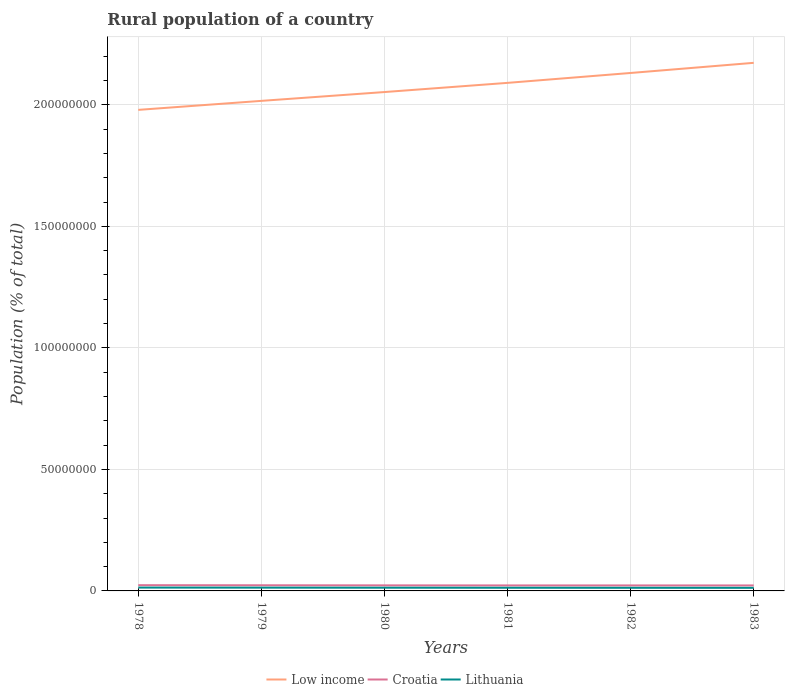How many different coloured lines are there?
Provide a short and direct response. 3. Is the number of lines equal to the number of legend labels?
Keep it short and to the point. Yes. Across all years, what is the maximum rural population in Low income?
Give a very brief answer. 1.98e+08. In which year was the rural population in Lithuania maximum?
Provide a short and direct response. 1983. What is the total rural population in Low income in the graph?
Your answer should be very brief. -3.78e+06. What is the difference between the highest and the second highest rural population in Croatia?
Provide a short and direct response. 1.10e+05. What is the difference between the highest and the lowest rural population in Low income?
Give a very brief answer. 3. How many years are there in the graph?
Provide a short and direct response. 6. Are the values on the major ticks of Y-axis written in scientific E-notation?
Keep it short and to the point. No. Does the graph contain any zero values?
Provide a succinct answer. No. What is the title of the graph?
Ensure brevity in your answer.  Rural population of a country. Does "Slovak Republic" appear as one of the legend labels in the graph?
Your response must be concise. No. What is the label or title of the X-axis?
Give a very brief answer. Years. What is the label or title of the Y-axis?
Offer a very short reply. Population (% of total). What is the Population (% of total) of Low income in 1978?
Your answer should be compact. 1.98e+08. What is the Population (% of total) of Croatia in 1978?
Keep it short and to the point. 2.37e+06. What is the Population (% of total) of Lithuania in 1978?
Provide a succinct answer. 1.37e+06. What is the Population (% of total) in Low income in 1979?
Your answer should be compact. 2.02e+08. What is the Population (% of total) in Croatia in 1979?
Your answer should be very brief. 2.33e+06. What is the Population (% of total) of Lithuania in 1979?
Make the answer very short. 1.35e+06. What is the Population (% of total) in Low income in 1980?
Your response must be concise. 2.05e+08. What is the Population (% of total) in Croatia in 1980?
Offer a terse response. 2.29e+06. What is the Population (% of total) in Lithuania in 1980?
Provide a succinct answer. 1.33e+06. What is the Population (% of total) of Low income in 1981?
Make the answer very short. 2.09e+08. What is the Population (% of total) in Croatia in 1981?
Offer a terse response. 2.26e+06. What is the Population (% of total) of Lithuania in 1981?
Provide a short and direct response. 1.31e+06. What is the Population (% of total) of Low income in 1982?
Your answer should be very brief. 2.13e+08. What is the Population (% of total) of Croatia in 1982?
Make the answer very short. 2.26e+06. What is the Population (% of total) in Lithuania in 1982?
Offer a terse response. 1.29e+06. What is the Population (% of total) of Low income in 1983?
Offer a very short reply. 2.17e+08. What is the Population (% of total) of Croatia in 1983?
Provide a succinct answer. 2.26e+06. What is the Population (% of total) of Lithuania in 1983?
Offer a very short reply. 1.27e+06. Across all years, what is the maximum Population (% of total) in Low income?
Offer a very short reply. 2.17e+08. Across all years, what is the maximum Population (% of total) in Croatia?
Offer a terse response. 2.37e+06. Across all years, what is the maximum Population (% of total) in Lithuania?
Ensure brevity in your answer.  1.37e+06. Across all years, what is the minimum Population (% of total) of Low income?
Give a very brief answer. 1.98e+08. Across all years, what is the minimum Population (% of total) in Croatia?
Your answer should be compact. 2.26e+06. Across all years, what is the minimum Population (% of total) in Lithuania?
Make the answer very short. 1.27e+06. What is the total Population (% of total) in Low income in the graph?
Provide a short and direct response. 1.24e+09. What is the total Population (% of total) of Croatia in the graph?
Give a very brief answer. 1.38e+07. What is the total Population (% of total) in Lithuania in the graph?
Give a very brief answer. 7.91e+06. What is the difference between the Population (% of total) in Low income in 1978 and that in 1979?
Provide a succinct answer. -3.70e+06. What is the difference between the Population (% of total) of Croatia in 1978 and that in 1979?
Provide a succinct answer. 3.74e+04. What is the difference between the Population (% of total) in Lithuania in 1978 and that in 1979?
Make the answer very short. 2.72e+04. What is the difference between the Population (% of total) in Low income in 1978 and that in 1980?
Offer a very short reply. -7.33e+06. What is the difference between the Population (% of total) of Croatia in 1978 and that in 1980?
Your response must be concise. 7.42e+04. What is the difference between the Population (% of total) in Lithuania in 1978 and that in 1980?
Ensure brevity in your answer.  4.83e+04. What is the difference between the Population (% of total) of Low income in 1978 and that in 1981?
Keep it short and to the point. -1.11e+07. What is the difference between the Population (% of total) in Croatia in 1978 and that in 1981?
Offer a terse response. 1.02e+05. What is the difference between the Population (% of total) in Lithuania in 1978 and that in 1981?
Provide a short and direct response. 6.77e+04. What is the difference between the Population (% of total) of Low income in 1978 and that in 1982?
Make the answer very short. -1.52e+07. What is the difference between the Population (% of total) of Croatia in 1978 and that in 1982?
Keep it short and to the point. 1.05e+05. What is the difference between the Population (% of total) in Lithuania in 1978 and that in 1982?
Your answer should be compact. 8.56e+04. What is the difference between the Population (% of total) of Low income in 1978 and that in 1983?
Provide a succinct answer. -1.94e+07. What is the difference between the Population (% of total) in Croatia in 1978 and that in 1983?
Your answer should be very brief. 1.10e+05. What is the difference between the Population (% of total) in Lithuania in 1978 and that in 1983?
Your answer should be very brief. 1.02e+05. What is the difference between the Population (% of total) in Low income in 1979 and that in 1980?
Keep it short and to the point. -3.63e+06. What is the difference between the Population (% of total) of Croatia in 1979 and that in 1980?
Your answer should be compact. 3.68e+04. What is the difference between the Population (% of total) in Lithuania in 1979 and that in 1980?
Provide a succinct answer. 2.11e+04. What is the difference between the Population (% of total) in Low income in 1979 and that in 1981?
Your response must be concise. -7.41e+06. What is the difference between the Population (% of total) of Croatia in 1979 and that in 1981?
Your answer should be compact. 6.49e+04. What is the difference between the Population (% of total) in Lithuania in 1979 and that in 1981?
Your response must be concise. 4.05e+04. What is the difference between the Population (% of total) of Low income in 1979 and that in 1982?
Offer a very short reply. -1.15e+07. What is the difference between the Population (% of total) in Croatia in 1979 and that in 1982?
Give a very brief answer. 6.79e+04. What is the difference between the Population (% of total) in Lithuania in 1979 and that in 1982?
Give a very brief answer. 5.84e+04. What is the difference between the Population (% of total) of Low income in 1979 and that in 1983?
Your answer should be very brief. -1.57e+07. What is the difference between the Population (% of total) in Croatia in 1979 and that in 1983?
Keep it short and to the point. 7.26e+04. What is the difference between the Population (% of total) of Lithuania in 1979 and that in 1983?
Offer a very short reply. 7.50e+04. What is the difference between the Population (% of total) of Low income in 1980 and that in 1981?
Offer a terse response. -3.78e+06. What is the difference between the Population (% of total) of Croatia in 1980 and that in 1981?
Keep it short and to the point. 2.81e+04. What is the difference between the Population (% of total) in Lithuania in 1980 and that in 1981?
Your answer should be very brief. 1.94e+04. What is the difference between the Population (% of total) in Low income in 1980 and that in 1982?
Keep it short and to the point. -7.85e+06. What is the difference between the Population (% of total) in Croatia in 1980 and that in 1982?
Provide a short and direct response. 3.11e+04. What is the difference between the Population (% of total) of Lithuania in 1980 and that in 1982?
Provide a succinct answer. 3.73e+04. What is the difference between the Population (% of total) of Low income in 1980 and that in 1983?
Offer a very short reply. -1.20e+07. What is the difference between the Population (% of total) in Croatia in 1980 and that in 1983?
Your answer should be very brief. 3.58e+04. What is the difference between the Population (% of total) of Lithuania in 1980 and that in 1983?
Offer a terse response. 5.39e+04. What is the difference between the Population (% of total) in Low income in 1981 and that in 1982?
Offer a very short reply. -4.07e+06. What is the difference between the Population (% of total) in Croatia in 1981 and that in 1982?
Your response must be concise. 3009. What is the difference between the Population (% of total) of Lithuania in 1981 and that in 1982?
Offer a terse response. 1.79e+04. What is the difference between the Population (% of total) in Low income in 1981 and that in 1983?
Give a very brief answer. -8.24e+06. What is the difference between the Population (% of total) in Croatia in 1981 and that in 1983?
Your answer should be very brief. 7659. What is the difference between the Population (% of total) in Lithuania in 1981 and that in 1983?
Your answer should be very brief. 3.45e+04. What is the difference between the Population (% of total) of Low income in 1982 and that in 1983?
Your answer should be compact. -4.17e+06. What is the difference between the Population (% of total) of Croatia in 1982 and that in 1983?
Your answer should be compact. 4650. What is the difference between the Population (% of total) in Lithuania in 1982 and that in 1983?
Keep it short and to the point. 1.66e+04. What is the difference between the Population (% of total) of Low income in 1978 and the Population (% of total) of Croatia in 1979?
Make the answer very short. 1.96e+08. What is the difference between the Population (% of total) of Low income in 1978 and the Population (% of total) of Lithuania in 1979?
Your answer should be compact. 1.97e+08. What is the difference between the Population (% of total) in Croatia in 1978 and the Population (% of total) in Lithuania in 1979?
Provide a short and direct response. 1.02e+06. What is the difference between the Population (% of total) of Low income in 1978 and the Population (% of total) of Croatia in 1980?
Provide a short and direct response. 1.96e+08. What is the difference between the Population (% of total) in Low income in 1978 and the Population (% of total) in Lithuania in 1980?
Keep it short and to the point. 1.97e+08. What is the difference between the Population (% of total) in Croatia in 1978 and the Population (% of total) in Lithuania in 1980?
Provide a short and direct response. 1.04e+06. What is the difference between the Population (% of total) of Low income in 1978 and the Population (% of total) of Croatia in 1981?
Your response must be concise. 1.96e+08. What is the difference between the Population (% of total) in Low income in 1978 and the Population (% of total) in Lithuania in 1981?
Provide a succinct answer. 1.97e+08. What is the difference between the Population (% of total) in Croatia in 1978 and the Population (% of total) in Lithuania in 1981?
Provide a short and direct response. 1.06e+06. What is the difference between the Population (% of total) in Low income in 1978 and the Population (% of total) in Croatia in 1982?
Give a very brief answer. 1.96e+08. What is the difference between the Population (% of total) in Low income in 1978 and the Population (% of total) in Lithuania in 1982?
Offer a terse response. 1.97e+08. What is the difference between the Population (% of total) in Croatia in 1978 and the Population (% of total) in Lithuania in 1982?
Your answer should be compact. 1.08e+06. What is the difference between the Population (% of total) of Low income in 1978 and the Population (% of total) of Croatia in 1983?
Offer a terse response. 1.96e+08. What is the difference between the Population (% of total) in Low income in 1978 and the Population (% of total) in Lithuania in 1983?
Give a very brief answer. 1.97e+08. What is the difference between the Population (% of total) of Croatia in 1978 and the Population (% of total) of Lithuania in 1983?
Keep it short and to the point. 1.09e+06. What is the difference between the Population (% of total) in Low income in 1979 and the Population (% of total) in Croatia in 1980?
Your answer should be compact. 1.99e+08. What is the difference between the Population (% of total) of Low income in 1979 and the Population (% of total) of Lithuania in 1980?
Your answer should be compact. 2.00e+08. What is the difference between the Population (% of total) in Croatia in 1979 and the Population (% of total) in Lithuania in 1980?
Your response must be concise. 1.00e+06. What is the difference between the Population (% of total) of Low income in 1979 and the Population (% of total) of Croatia in 1981?
Ensure brevity in your answer.  1.99e+08. What is the difference between the Population (% of total) of Low income in 1979 and the Population (% of total) of Lithuania in 1981?
Offer a very short reply. 2.00e+08. What is the difference between the Population (% of total) of Croatia in 1979 and the Population (% of total) of Lithuania in 1981?
Provide a short and direct response. 1.02e+06. What is the difference between the Population (% of total) of Low income in 1979 and the Population (% of total) of Croatia in 1982?
Your answer should be compact. 1.99e+08. What is the difference between the Population (% of total) in Low income in 1979 and the Population (% of total) in Lithuania in 1982?
Provide a short and direct response. 2.00e+08. What is the difference between the Population (% of total) in Croatia in 1979 and the Population (% of total) in Lithuania in 1982?
Your response must be concise. 1.04e+06. What is the difference between the Population (% of total) in Low income in 1979 and the Population (% of total) in Croatia in 1983?
Provide a short and direct response. 1.99e+08. What is the difference between the Population (% of total) in Low income in 1979 and the Population (% of total) in Lithuania in 1983?
Make the answer very short. 2.00e+08. What is the difference between the Population (% of total) of Croatia in 1979 and the Population (% of total) of Lithuania in 1983?
Offer a very short reply. 1.06e+06. What is the difference between the Population (% of total) of Low income in 1980 and the Population (% of total) of Croatia in 1981?
Give a very brief answer. 2.03e+08. What is the difference between the Population (% of total) of Low income in 1980 and the Population (% of total) of Lithuania in 1981?
Your response must be concise. 2.04e+08. What is the difference between the Population (% of total) of Croatia in 1980 and the Population (% of total) of Lithuania in 1981?
Ensure brevity in your answer.  9.85e+05. What is the difference between the Population (% of total) of Low income in 1980 and the Population (% of total) of Croatia in 1982?
Ensure brevity in your answer.  2.03e+08. What is the difference between the Population (% of total) of Low income in 1980 and the Population (% of total) of Lithuania in 1982?
Your answer should be very brief. 2.04e+08. What is the difference between the Population (% of total) in Croatia in 1980 and the Population (% of total) in Lithuania in 1982?
Your answer should be compact. 1.00e+06. What is the difference between the Population (% of total) in Low income in 1980 and the Population (% of total) in Croatia in 1983?
Ensure brevity in your answer.  2.03e+08. What is the difference between the Population (% of total) in Low income in 1980 and the Population (% of total) in Lithuania in 1983?
Keep it short and to the point. 2.04e+08. What is the difference between the Population (% of total) in Croatia in 1980 and the Population (% of total) in Lithuania in 1983?
Provide a succinct answer. 1.02e+06. What is the difference between the Population (% of total) in Low income in 1981 and the Population (% of total) in Croatia in 1982?
Offer a terse response. 2.07e+08. What is the difference between the Population (% of total) of Low income in 1981 and the Population (% of total) of Lithuania in 1982?
Give a very brief answer. 2.08e+08. What is the difference between the Population (% of total) in Croatia in 1981 and the Population (% of total) in Lithuania in 1982?
Keep it short and to the point. 9.75e+05. What is the difference between the Population (% of total) in Low income in 1981 and the Population (% of total) in Croatia in 1983?
Give a very brief answer. 2.07e+08. What is the difference between the Population (% of total) of Low income in 1981 and the Population (% of total) of Lithuania in 1983?
Provide a succinct answer. 2.08e+08. What is the difference between the Population (% of total) of Croatia in 1981 and the Population (% of total) of Lithuania in 1983?
Your response must be concise. 9.91e+05. What is the difference between the Population (% of total) of Low income in 1982 and the Population (% of total) of Croatia in 1983?
Your response must be concise. 2.11e+08. What is the difference between the Population (% of total) of Low income in 1982 and the Population (% of total) of Lithuania in 1983?
Your response must be concise. 2.12e+08. What is the difference between the Population (% of total) of Croatia in 1982 and the Population (% of total) of Lithuania in 1983?
Offer a terse response. 9.88e+05. What is the average Population (% of total) in Low income per year?
Provide a succinct answer. 2.07e+08. What is the average Population (% of total) in Croatia per year?
Your response must be concise. 2.29e+06. What is the average Population (% of total) of Lithuania per year?
Your response must be concise. 1.32e+06. In the year 1978, what is the difference between the Population (% of total) of Low income and Population (% of total) of Croatia?
Provide a short and direct response. 1.96e+08. In the year 1978, what is the difference between the Population (% of total) of Low income and Population (% of total) of Lithuania?
Provide a short and direct response. 1.97e+08. In the year 1978, what is the difference between the Population (% of total) of Croatia and Population (% of total) of Lithuania?
Provide a succinct answer. 9.91e+05. In the year 1979, what is the difference between the Population (% of total) in Low income and Population (% of total) in Croatia?
Ensure brevity in your answer.  1.99e+08. In the year 1979, what is the difference between the Population (% of total) of Low income and Population (% of total) of Lithuania?
Give a very brief answer. 2.00e+08. In the year 1979, what is the difference between the Population (% of total) of Croatia and Population (% of total) of Lithuania?
Your response must be concise. 9.81e+05. In the year 1980, what is the difference between the Population (% of total) in Low income and Population (% of total) in Croatia?
Your answer should be very brief. 2.03e+08. In the year 1980, what is the difference between the Population (% of total) in Low income and Population (% of total) in Lithuania?
Provide a short and direct response. 2.04e+08. In the year 1980, what is the difference between the Population (% of total) of Croatia and Population (% of total) of Lithuania?
Provide a succinct answer. 9.65e+05. In the year 1981, what is the difference between the Population (% of total) in Low income and Population (% of total) in Croatia?
Offer a very short reply. 2.07e+08. In the year 1981, what is the difference between the Population (% of total) in Low income and Population (% of total) in Lithuania?
Your response must be concise. 2.08e+08. In the year 1981, what is the difference between the Population (% of total) in Croatia and Population (% of total) in Lithuania?
Offer a very short reply. 9.57e+05. In the year 1982, what is the difference between the Population (% of total) in Low income and Population (% of total) in Croatia?
Provide a succinct answer. 2.11e+08. In the year 1982, what is the difference between the Population (% of total) in Low income and Population (% of total) in Lithuania?
Your response must be concise. 2.12e+08. In the year 1982, what is the difference between the Population (% of total) in Croatia and Population (% of total) in Lithuania?
Give a very brief answer. 9.72e+05. In the year 1983, what is the difference between the Population (% of total) of Low income and Population (% of total) of Croatia?
Provide a short and direct response. 2.15e+08. In the year 1983, what is the difference between the Population (% of total) of Low income and Population (% of total) of Lithuania?
Give a very brief answer. 2.16e+08. In the year 1983, what is the difference between the Population (% of total) of Croatia and Population (% of total) of Lithuania?
Make the answer very short. 9.84e+05. What is the ratio of the Population (% of total) of Low income in 1978 to that in 1979?
Your response must be concise. 0.98. What is the ratio of the Population (% of total) in Croatia in 1978 to that in 1979?
Your response must be concise. 1.02. What is the ratio of the Population (% of total) in Lithuania in 1978 to that in 1979?
Ensure brevity in your answer.  1.02. What is the ratio of the Population (% of total) of Low income in 1978 to that in 1980?
Provide a succinct answer. 0.96. What is the ratio of the Population (% of total) of Croatia in 1978 to that in 1980?
Your response must be concise. 1.03. What is the ratio of the Population (% of total) of Lithuania in 1978 to that in 1980?
Offer a very short reply. 1.04. What is the ratio of the Population (% of total) of Low income in 1978 to that in 1981?
Give a very brief answer. 0.95. What is the ratio of the Population (% of total) in Croatia in 1978 to that in 1981?
Make the answer very short. 1.05. What is the ratio of the Population (% of total) of Lithuania in 1978 to that in 1981?
Your response must be concise. 1.05. What is the ratio of the Population (% of total) of Low income in 1978 to that in 1982?
Make the answer very short. 0.93. What is the ratio of the Population (% of total) of Croatia in 1978 to that in 1982?
Offer a terse response. 1.05. What is the ratio of the Population (% of total) in Lithuania in 1978 to that in 1982?
Keep it short and to the point. 1.07. What is the ratio of the Population (% of total) in Low income in 1978 to that in 1983?
Give a very brief answer. 0.91. What is the ratio of the Population (% of total) of Croatia in 1978 to that in 1983?
Offer a very short reply. 1.05. What is the ratio of the Population (% of total) in Lithuania in 1978 to that in 1983?
Make the answer very short. 1.08. What is the ratio of the Population (% of total) in Low income in 1979 to that in 1980?
Your answer should be very brief. 0.98. What is the ratio of the Population (% of total) of Croatia in 1979 to that in 1980?
Provide a short and direct response. 1.02. What is the ratio of the Population (% of total) of Lithuania in 1979 to that in 1980?
Make the answer very short. 1.02. What is the ratio of the Population (% of total) in Low income in 1979 to that in 1981?
Your response must be concise. 0.96. What is the ratio of the Population (% of total) in Croatia in 1979 to that in 1981?
Keep it short and to the point. 1.03. What is the ratio of the Population (% of total) in Lithuania in 1979 to that in 1981?
Offer a terse response. 1.03. What is the ratio of the Population (% of total) of Low income in 1979 to that in 1982?
Ensure brevity in your answer.  0.95. What is the ratio of the Population (% of total) of Croatia in 1979 to that in 1982?
Keep it short and to the point. 1.03. What is the ratio of the Population (% of total) in Lithuania in 1979 to that in 1982?
Your answer should be compact. 1.05. What is the ratio of the Population (% of total) in Low income in 1979 to that in 1983?
Make the answer very short. 0.93. What is the ratio of the Population (% of total) in Croatia in 1979 to that in 1983?
Keep it short and to the point. 1.03. What is the ratio of the Population (% of total) of Lithuania in 1979 to that in 1983?
Your answer should be compact. 1.06. What is the ratio of the Population (% of total) in Low income in 1980 to that in 1981?
Your response must be concise. 0.98. What is the ratio of the Population (% of total) in Croatia in 1980 to that in 1981?
Your response must be concise. 1.01. What is the ratio of the Population (% of total) of Lithuania in 1980 to that in 1981?
Offer a very short reply. 1.01. What is the ratio of the Population (% of total) in Low income in 1980 to that in 1982?
Provide a succinct answer. 0.96. What is the ratio of the Population (% of total) in Croatia in 1980 to that in 1982?
Provide a short and direct response. 1.01. What is the ratio of the Population (% of total) in Lithuania in 1980 to that in 1982?
Offer a terse response. 1.03. What is the ratio of the Population (% of total) in Low income in 1980 to that in 1983?
Keep it short and to the point. 0.94. What is the ratio of the Population (% of total) of Croatia in 1980 to that in 1983?
Your answer should be very brief. 1.02. What is the ratio of the Population (% of total) of Lithuania in 1980 to that in 1983?
Your answer should be compact. 1.04. What is the ratio of the Population (% of total) in Low income in 1981 to that in 1982?
Your answer should be compact. 0.98. What is the ratio of the Population (% of total) of Lithuania in 1981 to that in 1982?
Offer a terse response. 1.01. What is the ratio of the Population (% of total) in Low income in 1981 to that in 1983?
Keep it short and to the point. 0.96. What is the ratio of the Population (% of total) in Croatia in 1981 to that in 1983?
Offer a very short reply. 1. What is the ratio of the Population (% of total) in Lithuania in 1981 to that in 1983?
Keep it short and to the point. 1.03. What is the ratio of the Population (% of total) of Low income in 1982 to that in 1983?
Make the answer very short. 0.98. What is the ratio of the Population (% of total) of Lithuania in 1982 to that in 1983?
Make the answer very short. 1.01. What is the difference between the highest and the second highest Population (% of total) in Low income?
Offer a very short reply. 4.17e+06. What is the difference between the highest and the second highest Population (% of total) in Croatia?
Provide a short and direct response. 3.74e+04. What is the difference between the highest and the second highest Population (% of total) of Lithuania?
Keep it short and to the point. 2.72e+04. What is the difference between the highest and the lowest Population (% of total) of Low income?
Ensure brevity in your answer.  1.94e+07. What is the difference between the highest and the lowest Population (% of total) of Croatia?
Offer a terse response. 1.10e+05. What is the difference between the highest and the lowest Population (% of total) of Lithuania?
Your answer should be compact. 1.02e+05. 